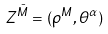Convert formula to latex. <formula><loc_0><loc_0><loc_500><loc_500>Z ^ { \bar { M } } = ( \rho ^ { M } , \theta ^ { \alpha } )</formula> 